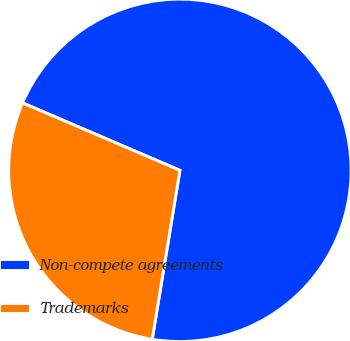<chart> <loc_0><loc_0><loc_500><loc_500><pie_chart><fcel>Non-compete agreements<fcel>Trademarks<nl><fcel>71.14%<fcel>28.86%<nl></chart> 